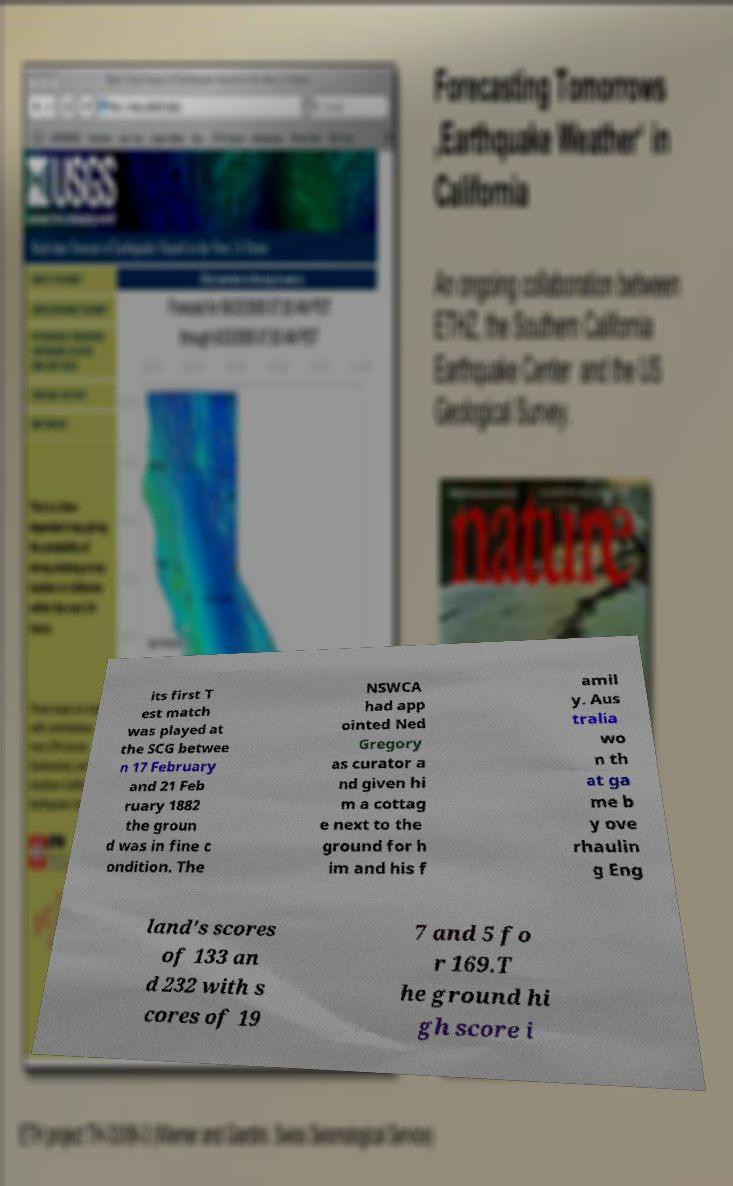I need the written content from this picture converted into text. Can you do that? its first T est match was played at the SCG betwee n 17 February and 21 Feb ruary 1882 the groun d was in fine c ondition. The NSWCA had app ointed Ned Gregory as curator a nd given hi m a cottag e next to the ground for h im and his f amil y. Aus tralia wo n th at ga me b y ove rhaulin g Eng land's scores of 133 an d 232 with s cores of 19 7 and 5 fo r 169.T he ground hi gh score i 